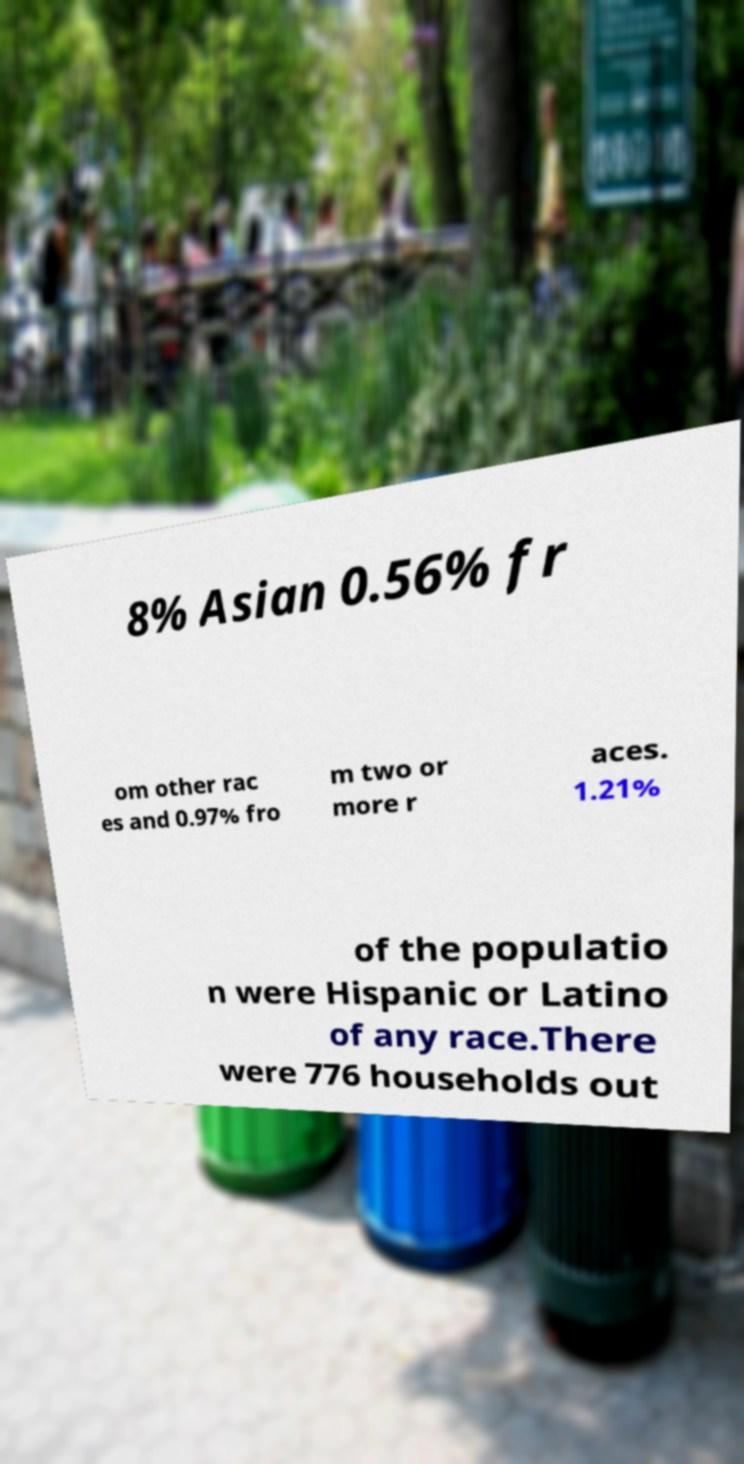I need the written content from this picture converted into text. Can you do that? 8% Asian 0.56% fr om other rac es and 0.97% fro m two or more r aces. 1.21% of the populatio n were Hispanic or Latino of any race.There were 776 households out 